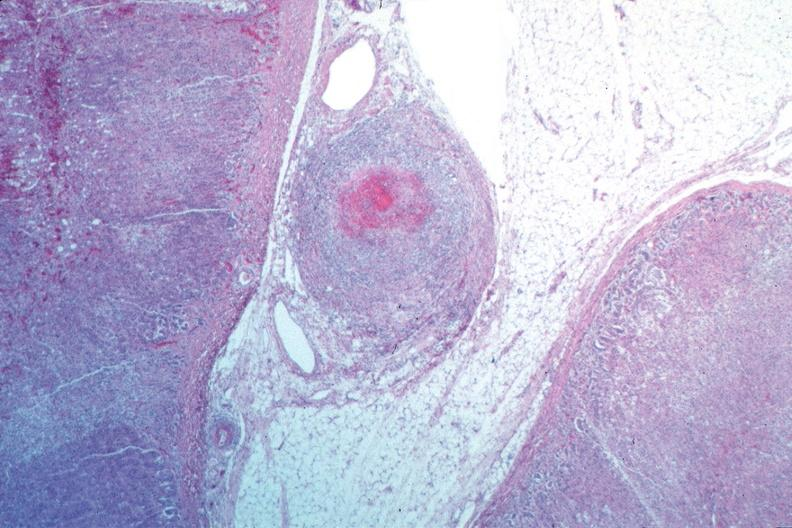what is present?
Answer the question using a single word or phrase. Vasculature 